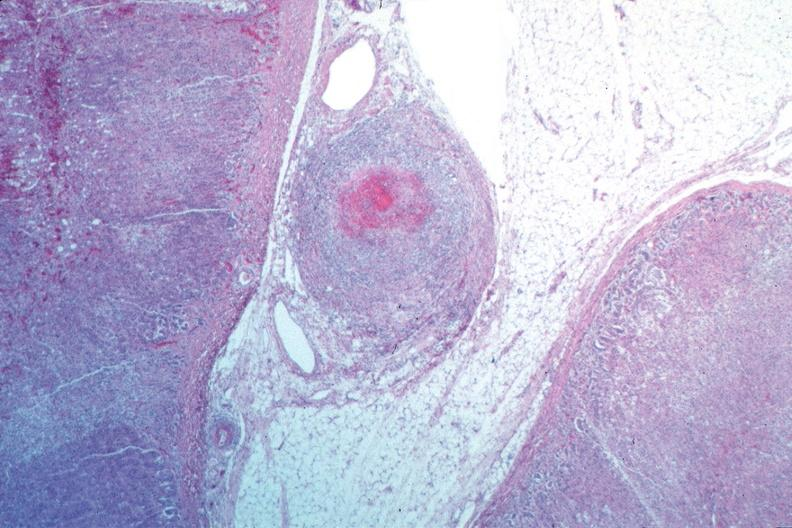what is present?
Answer the question using a single word or phrase. Vasculature 